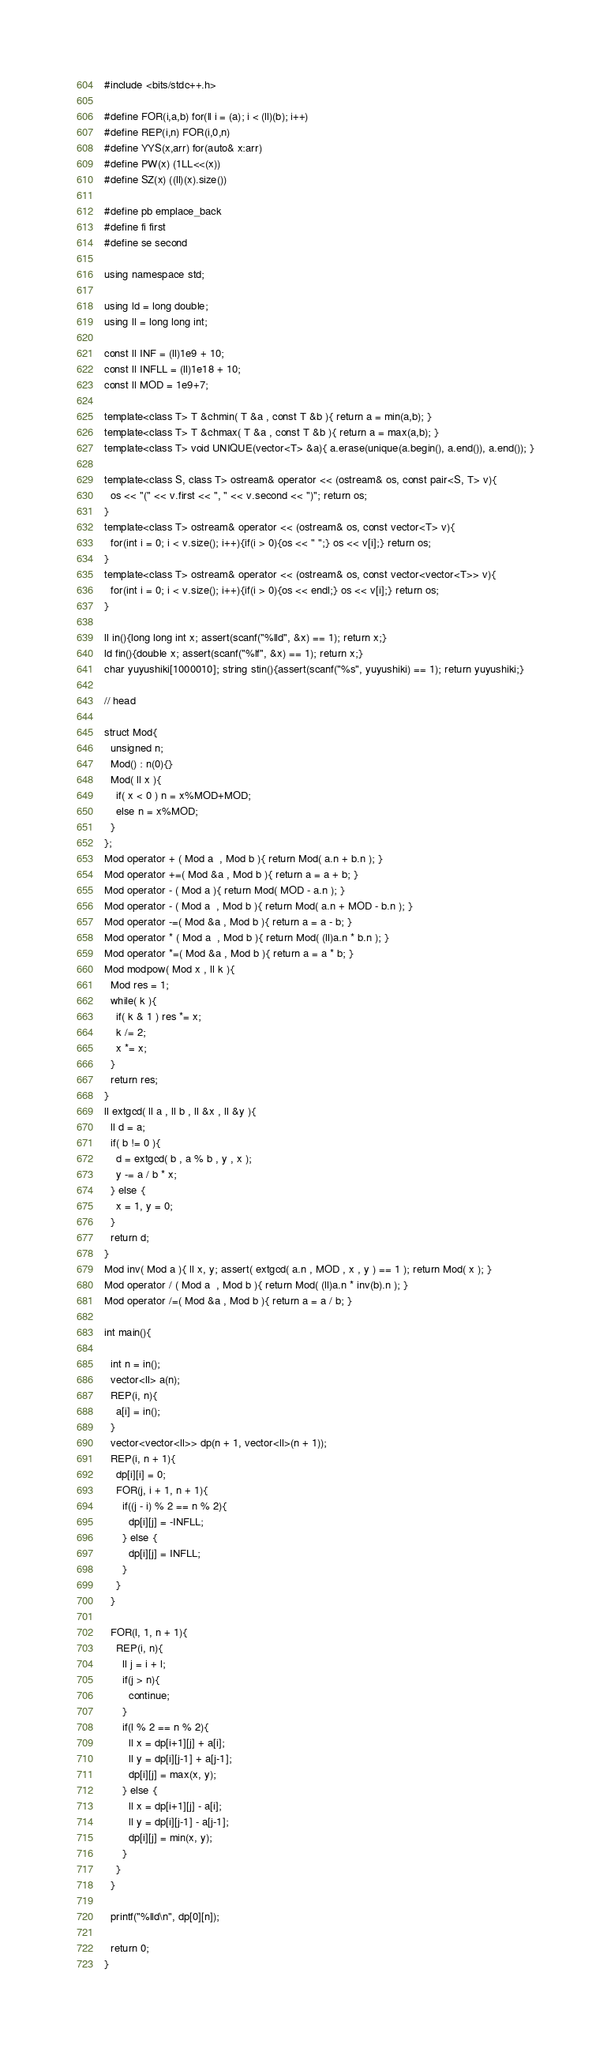<code> <loc_0><loc_0><loc_500><loc_500><_C++_>#include <bits/stdc++.h>
      
#define FOR(i,a,b) for(ll i = (a); i < (ll)(b); i++)
#define REP(i,n) FOR(i,0,n)
#define YYS(x,arr) for(auto& x:arr)
#define PW(x) (1LL<<(x))
#define SZ(x) ((ll)(x).size())

#define pb emplace_back
#define fi first
#define se second

using namespace std;

using ld = long double;
using ll = long long int;

const ll INF = (ll)1e9 + 10;
const ll INFLL = (ll)1e18 + 10;
const ll MOD = 1e9+7;
     
template<class T> T &chmin( T &a , const T &b ){ return a = min(a,b); }
template<class T> T &chmax( T &a , const T &b ){ return a = max(a,b); }
template<class T> void UNIQUE(vector<T> &a){ a.erase(unique(a.begin(), a.end()), a.end()); }

template<class S, class T> ostream& operator << (ostream& os, const pair<S, T> v){
  os << "(" << v.first << ", " << v.second << ")"; return os;
}
template<class T> ostream& operator << (ostream& os, const vector<T> v){
  for(int i = 0; i < v.size(); i++){if(i > 0){os << " ";} os << v[i];} return os;
}
template<class T> ostream& operator << (ostream& os, const vector<vector<T>> v){
  for(int i = 0; i < v.size(); i++){if(i > 0){os << endl;} os << v[i];} return os;
}

ll in(){long long int x; assert(scanf("%lld", &x) == 1); return x;}
ld fin(){double x; assert(scanf("%lf", &x) == 1); return x;}
char yuyushiki[1000010]; string stin(){assert(scanf("%s", yuyushiki) == 1); return yuyushiki;}

// head

struct Mod{
  unsigned n;
  Mod() : n(0){}
  Mod( ll x ){
    if( x < 0 ) n = x%MOD+MOD;
    else n = x%MOD;
  }
};
Mod operator + ( Mod a  , Mod b ){ return Mod( a.n + b.n ); }
Mod operator +=( Mod &a , Mod b ){ return a = a + b; }
Mod operator - ( Mod a ){ return Mod( MOD - a.n ); }
Mod operator - ( Mod a  , Mod b ){ return Mod( a.n + MOD - b.n ); }
Mod operator -=( Mod &a , Mod b ){ return a = a - b; }
Mod operator * ( Mod a  , Mod b ){ return Mod( (ll)a.n * b.n ); }
Mod operator *=( Mod &a , Mod b ){ return a = a * b; }
Mod modpow( Mod x , ll k ){
  Mod res = 1;
  while( k ){
    if( k & 1 ) res *= x;
    k /= 2;
    x *= x;
  }
  return res;
}
ll extgcd( ll a , ll b , ll &x , ll &y ){
  ll d = a;
  if( b != 0 ){
    d = extgcd( b , a % b , y , x );
    y -= a / b * x;
  } else {
    x = 1, y = 0;
  }
  return d;
}
Mod inv( Mod a ){ ll x, y; assert( extgcd( a.n , MOD , x , y ) == 1 ); return Mod( x ); }
Mod operator / ( Mod a  , Mod b ){ return Mod( (ll)a.n * inv(b).n ); }
Mod operator /=( Mod &a , Mod b ){ return a = a / b; }

int main(){

  int n = in();
  vector<ll> a(n);
  REP(i, n){
    a[i] = in();
  }
  vector<vector<ll>> dp(n + 1, vector<ll>(n + 1));
  REP(i, n + 1){
    dp[i][i] = 0;
    FOR(j, i + 1, n + 1){
      if((j - i) % 2 == n % 2){
        dp[i][j] = -INFLL;
      } else {
        dp[i][j] = INFLL;
      }
    }
  }
  
  FOR(l, 1, n + 1){
    REP(i, n){
      ll j = i + l;
      if(j > n){
        continue;
      }
      if(l % 2 == n % 2){
        ll x = dp[i+1][j] + a[i];
        ll y = dp[i][j-1] + a[j-1];
        dp[i][j] = max(x, y);
      } else {
        ll x = dp[i+1][j] - a[i];
        ll y = dp[i][j-1] - a[j-1];
        dp[i][j] = min(x, y);
      }
    }
  }

  printf("%lld\n", dp[0][n]);
  
  return 0;
}
</code> 